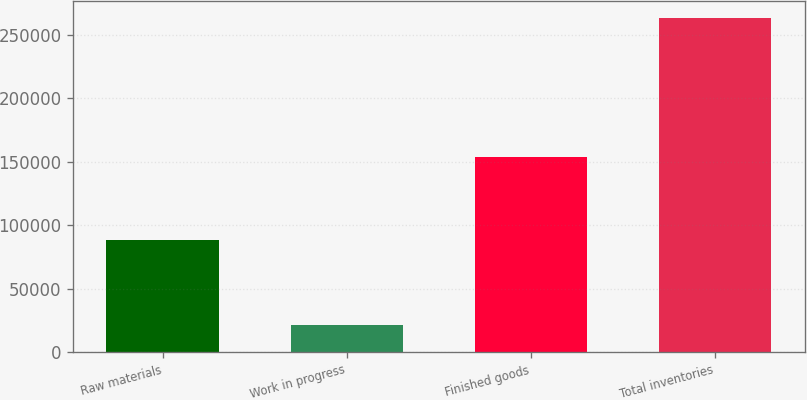Convert chart to OTSL. <chart><loc_0><loc_0><loc_500><loc_500><bar_chart><fcel>Raw materials<fcel>Work in progress<fcel>Finished goods<fcel>Total inventories<nl><fcel>88625<fcel>20901<fcel>153889<fcel>263415<nl></chart> 